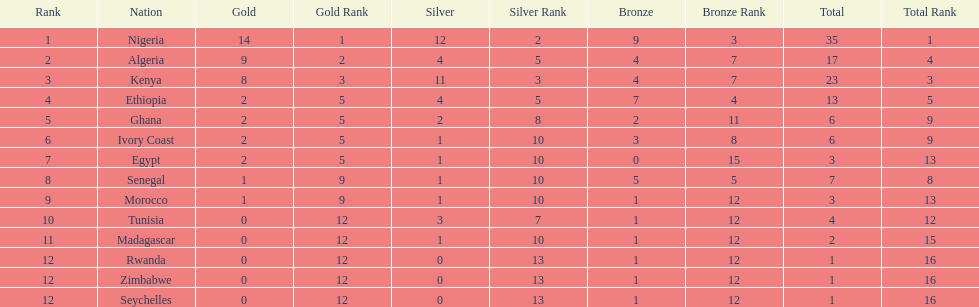What is the name of the first nation on this chart? Nigeria. 